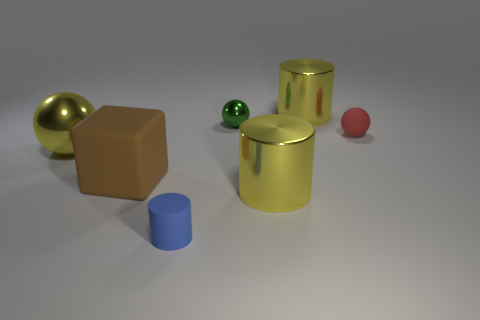Add 3 small blue rubber objects. How many objects exist? 10 Subtract all blocks. How many objects are left? 6 Subtract all yellow metallic cylinders. Subtract all big yellow things. How many objects are left? 2 Add 7 small red rubber balls. How many small red rubber balls are left? 8 Add 1 cubes. How many cubes exist? 2 Subtract 0 cyan balls. How many objects are left? 7 